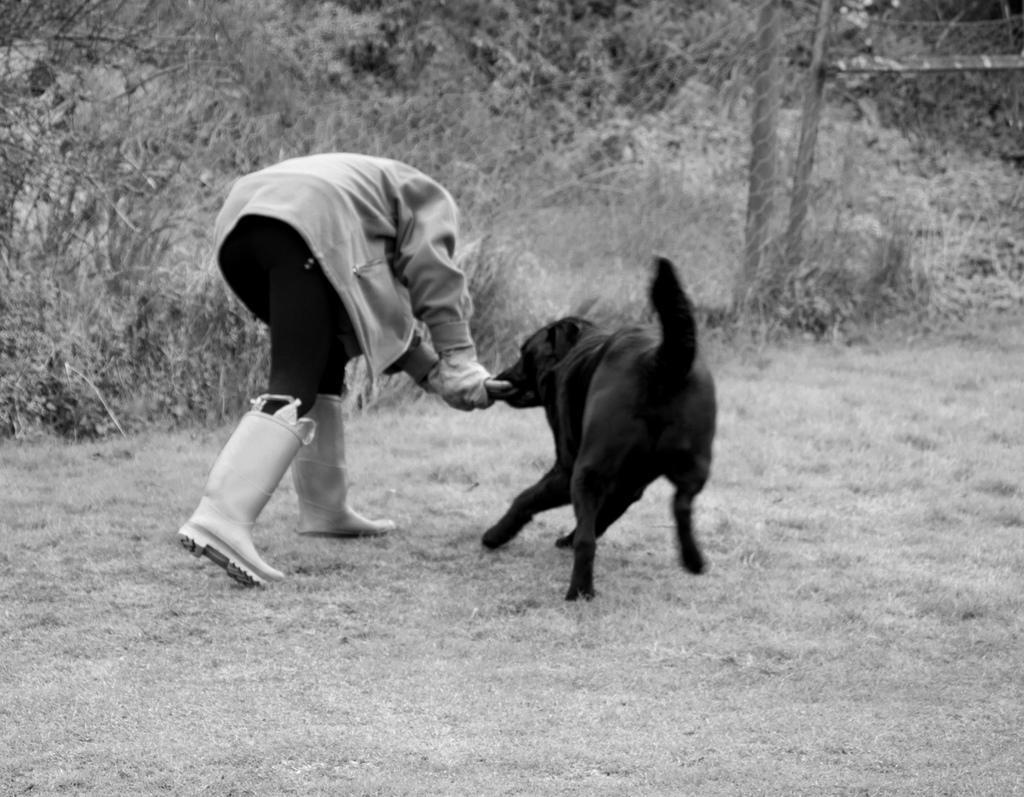In one or two sentences, can you explain what this image depicts? This is a black and white picture. On the background we can see plants. Here we can see a person playing with a black colour dog. 